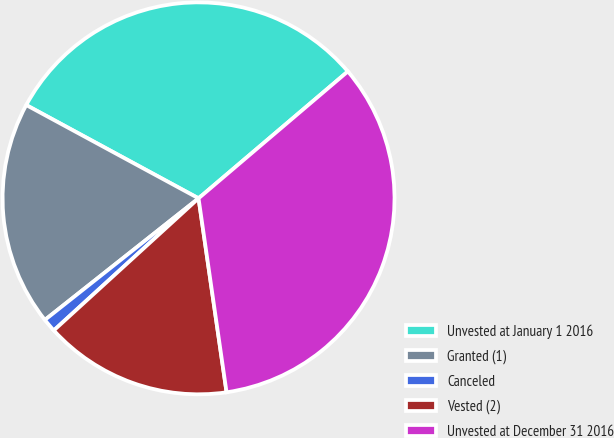Convert chart. <chart><loc_0><loc_0><loc_500><loc_500><pie_chart><fcel>Unvested at January 1 2016<fcel>Granted (1)<fcel>Canceled<fcel>Vested (2)<fcel>Unvested at December 31 2016<nl><fcel>30.89%<fcel>18.55%<fcel>1.12%<fcel>15.51%<fcel>33.93%<nl></chart> 